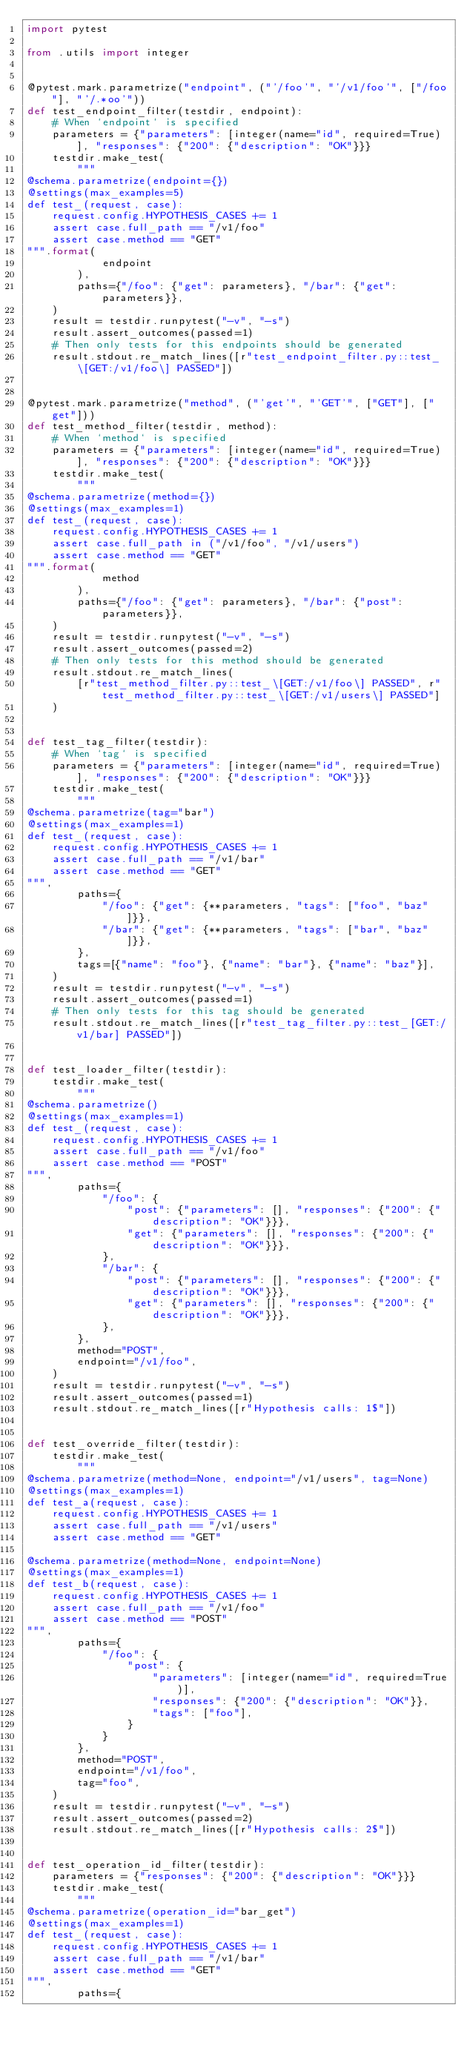<code> <loc_0><loc_0><loc_500><loc_500><_Python_>import pytest

from .utils import integer


@pytest.mark.parametrize("endpoint", ("'/foo'", "'/v1/foo'", ["/foo"], "'/.*oo'"))
def test_endpoint_filter(testdir, endpoint):
    # When `endpoint` is specified
    parameters = {"parameters": [integer(name="id", required=True)], "responses": {"200": {"description": "OK"}}}
    testdir.make_test(
        """
@schema.parametrize(endpoint={})
@settings(max_examples=5)
def test_(request, case):
    request.config.HYPOTHESIS_CASES += 1
    assert case.full_path == "/v1/foo"
    assert case.method == "GET"
""".format(
            endpoint
        ),
        paths={"/foo": {"get": parameters}, "/bar": {"get": parameters}},
    )
    result = testdir.runpytest("-v", "-s")
    result.assert_outcomes(passed=1)
    # Then only tests for this endpoints should be generated
    result.stdout.re_match_lines([r"test_endpoint_filter.py::test_\[GET:/v1/foo\] PASSED"])


@pytest.mark.parametrize("method", ("'get'", "'GET'", ["GET"], ["get"]))
def test_method_filter(testdir, method):
    # When `method` is specified
    parameters = {"parameters": [integer(name="id", required=True)], "responses": {"200": {"description": "OK"}}}
    testdir.make_test(
        """
@schema.parametrize(method={})
@settings(max_examples=1)
def test_(request, case):
    request.config.HYPOTHESIS_CASES += 1
    assert case.full_path in ("/v1/foo", "/v1/users")
    assert case.method == "GET"
""".format(
            method
        ),
        paths={"/foo": {"get": parameters}, "/bar": {"post": parameters}},
    )
    result = testdir.runpytest("-v", "-s")
    result.assert_outcomes(passed=2)
    # Then only tests for this method should be generated
    result.stdout.re_match_lines(
        [r"test_method_filter.py::test_\[GET:/v1/foo\] PASSED", r"test_method_filter.py::test_\[GET:/v1/users\] PASSED"]
    )


def test_tag_filter(testdir):
    # When `tag` is specified
    parameters = {"parameters": [integer(name="id", required=True)], "responses": {"200": {"description": "OK"}}}
    testdir.make_test(
        """
@schema.parametrize(tag="bar")
@settings(max_examples=1)
def test_(request, case):
    request.config.HYPOTHESIS_CASES += 1
    assert case.full_path == "/v1/bar"
    assert case.method == "GET"
""",
        paths={
            "/foo": {"get": {**parameters, "tags": ["foo", "baz"]}},
            "/bar": {"get": {**parameters, "tags": ["bar", "baz"]}},
        },
        tags=[{"name": "foo"}, {"name": "bar"}, {"name": "baz"}],
    )
    result = testdir.runpytest("-v", "-s")
    result.assert_outcomes(passed=1)
    # Then only tests for this tag should be generated
    result.stdout.re_match_lines([r"test_tag_filter.py::test_[GET:/v1/bar] PASSED"])


def test_loader_filter(testdir):
    testdir.make_test(
        """
@schema.parametrize()
@settings(max_examples=1)
def test_(request, case):
    request.config.HYPOTHESIS_CASES += 1
    assert case.full_path == "/v1/foo"
    assert case.method == "POST"
""",
        paths={
            "/foo": {
                "post": {"parameters": [], "responses": {"200": {"description": "OK"}}},
                "get": {"parameters": [], "responses": {"200": {"description": "OK"}}},
            },
            "/bar": {
                "post": {"parameters": [], "responses": {"200": {"description": "OK"}}},
                "get": {"parameters": [], "responses": {"200": {"description": "OK"}}},
            },
        },
        method="POST",
        endpoint="/v1/foo",
    )
    result = testdir.runpytest("-v", "-s")
    result.assert_outcomes(passed=1)
    result.stdout.re_match_lines([r"Hypothesis calls: 1$"])


def test_override_filter(testdir):
    testdir.make_test(
        """
@schema.parametrize(method=None, endpoint="/v1/users", tag=None)
@settings(max_examples=1)
def test_a(request, case):
    request.config.HYPOTHESIS_CASES += 1
    assert case.full_path == "/v1/users"
    assert case.method == "GET"

@schema.parametrize(method=None, endpoint=None)
@settings(max_examples=1)
def test_b(request, case):
    request.config.HYPOTHESIS_CASES += 1
    assert case.full_path == "/v1/foo"
    assert case.method == "POST"
""",
        paths={
            "/foo": {
                "post": {
                    "parameters": [integer(name="id", required=True)],
                    "responses": {"200": {"description": "OK"}},
                    "tags": ["foo"],
                }
            }
        },
        method="POST",
        endpoint="/v1/foo",
        tag="foo",
    )
    result = testdir.runpytest("-v", "-s")
    result.assert_outcomes(passed=2)
    result.stdout.re_match_lines([r"Hypothesis calls: 2$"])


def test_operation_id_filter(testdir):
    parameters = {"responses": {"200": {"description": "OK"}}}
    testdir.make_test(
        """
@schema.parametrize(operation_id="bar_get")
@settings(max_examples=1)
def test_(request, case):
    request.config.HYPOTHESIS_CASES += 1
    assert case.full_path == "/v1/bar"
    assert case.method == "GET"
""",
        paths={</code> 